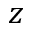<formula> <loc_0><loc_0><loc_500><loc_500>z</formula> 